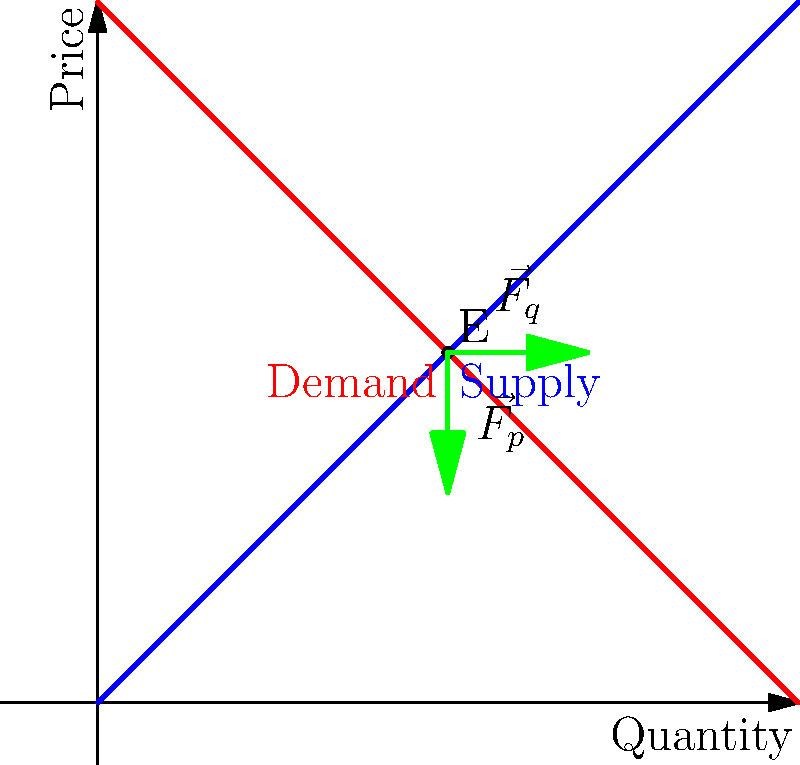In the supply and demand equilibrium diagram, two force vectors ($\vec{F_q}$ and $\vec{F_p}$) are shown at the equilibrium point E. If these vectors represent market pressures, how would you interpret their combined effect on the equilibrium state? Consider the patience required in trading to benefit from these forces. To analyze the force vectors in the supply and demand equilibrium diagram:

1. Identify the vectors:
   $\vec{F_q}$ points horizontally to the right (increasing quantity)
   $\vec{F_p}$ points vertically downward (decreasing price)

2. Interpret the vectors:
   $\vec{F_q}$ represents pressure to increase quantity
   $\vec{F_p}$ represents pressure to decrease price

3. Combined effect:
   The vectors form a resultant force pointing towards the lower right quadrant of the diagram.

4. Market interpretation:
   This indicates a tendency for the market to move towards higher quantity and lower price.

5. Equilibrium state:
   The presence of these forces at the equilibrium point suggests that the market is in a dynamic balance, constantly adjusting to these pressures.

6. Trading implications:
   Patience in trading is crucial here. The forces indicate potential short-term fluctuations around the equilibrium, but the market tends to return to this point.

7. Trading strategy:
   Patient traders can capitalize on these movements by:
   a) Buying when price temporarily drops below equilibrium
   b) Selling when price temporarily rises above equilibrium

8. Long-term perspective:
   The persistent nature of these forces at equilibrium suggests that patient traders who understand these dynamics can benefit from the market's tendency to revert to equilibrium.
Answer: The combined effect indicates short-term fluctuations around equilibrium, rewarding patient traders who capitalize on temporary deviations. 